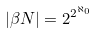Convert formula to latex. <formula><loc_0><loc_0><loc_500><loc_500>| \beta N | = 2 ^ { 2 ^ { \aleph _ { 0 } } }</formula> 